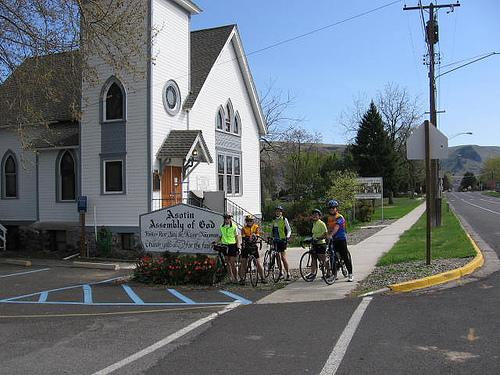Have they started their bike ride yet?
Concise answer only. No. Is this church open?
Concise answer only. Yes. Do these people believe in God?
Short answer required. Yes. 